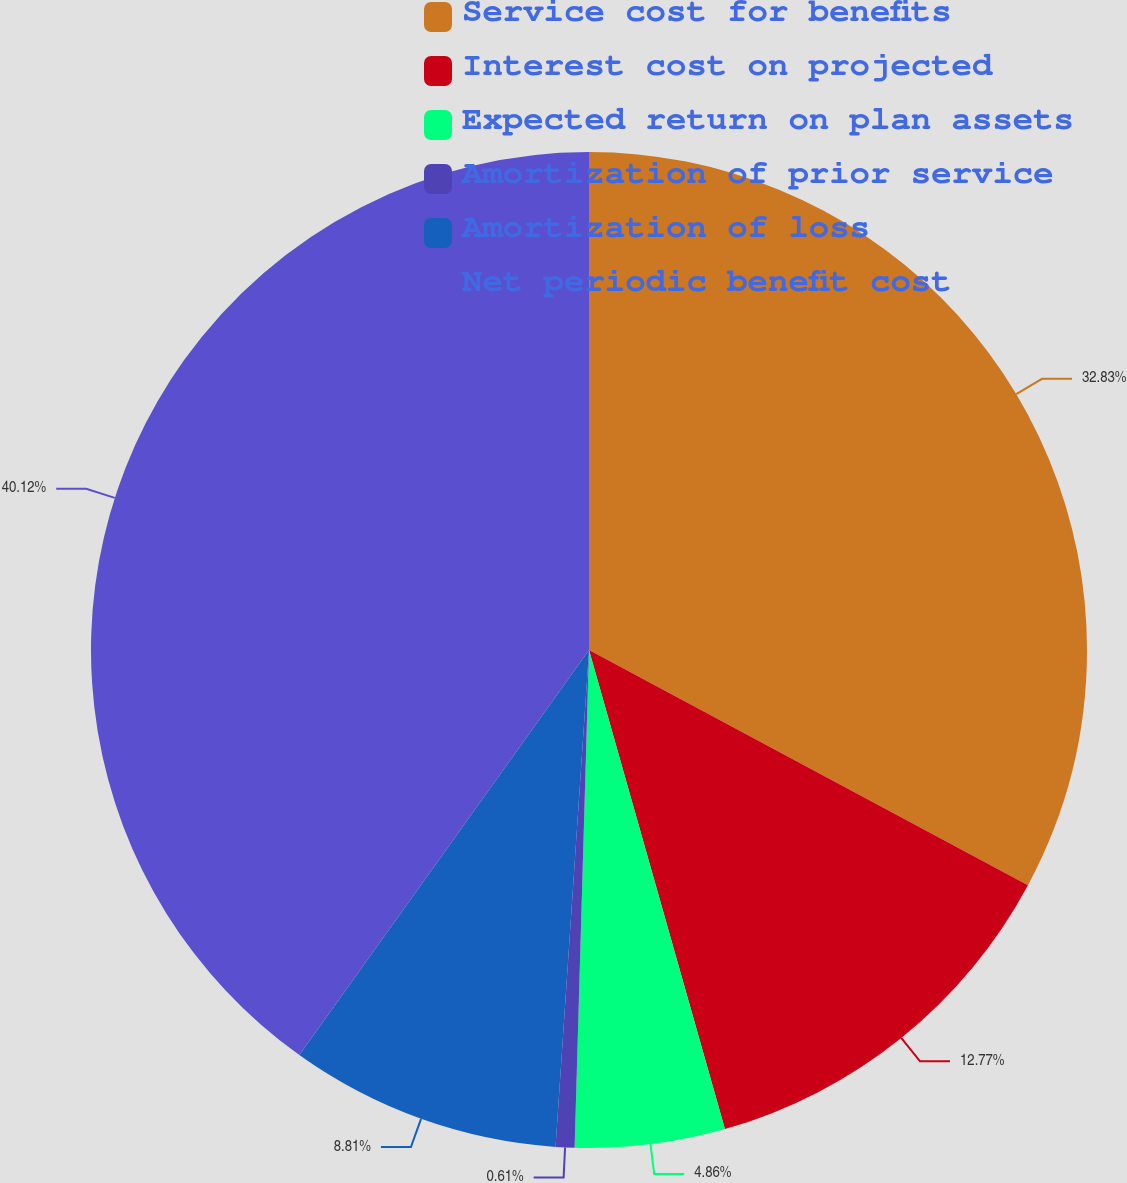Convert chart. <chart><loc_0><loc_0><loc_500><loc_500><pie_chart><fcel>Service cost for benefits<fcel>Interest cost on projected<fcel>Expected return on plan assets<fcel>Amortization of prior service<fcel>Amortization of loss<fcel>Net periodic benefit cost<nl><fcel>32.83%<fcel>12.77%<fcel>4.86%<fcel>0.61%<fcel>8.81%<fcel>40.12%<nl></chart> 